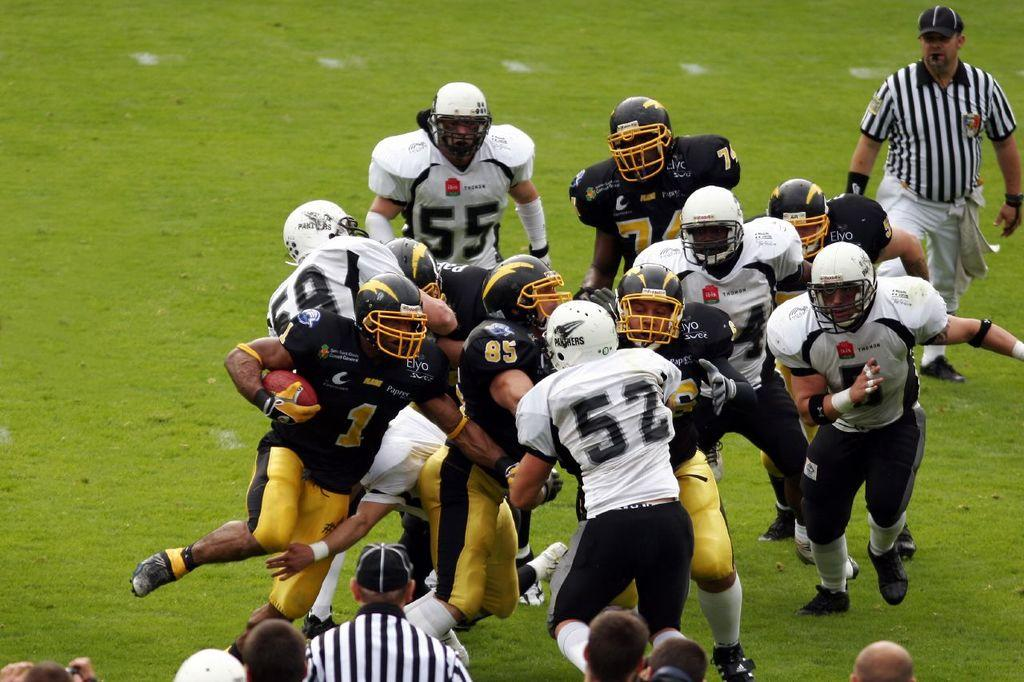What are the people in the image doing? The people in the image are playing a game. What protective gear are the people wearing? The people are wearing helmets. What is the ground covered with in the image? There is green grass on the ground. What type of meat is being served at the table in the image? There is no table or meat present in the image; it features people playing a game on green grass. 